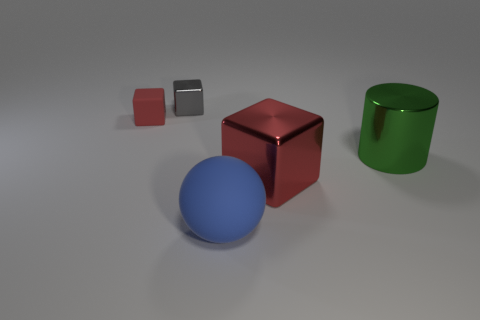Subtract all purple spheres. How many red blocks are left? 2 Subtract 1 blocks. How many blocks are left? 2 Subtract all shiny cubes. How many cubes are left? 1 Add 3 tiny metal things. How many objects exist? 8 Subtract 0 yellow blocks. How many objects are left? 5 Subtract all blocks. How many objects are left? 2 Subtract all small matte blocks. Subtract all small objects. How many objects are left? 2 Add 3 green cylinders. How many green cylinders are left? 4 Add 4 tiny red objects. How many tiny red objects exist? 5 